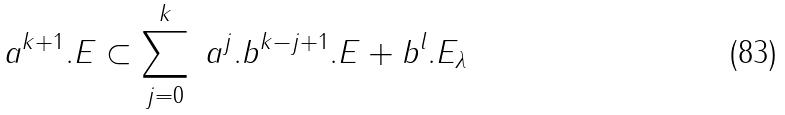Convert formula to latex. <formula><loc_0><loc_0><loc_500><loc_500>a ^ { k + 1 } . E \subset \sum _ { j = 0 } ^ { k } \ a ^ { j } . b ^ { k - j + 1 } . E + b ^ { l } . E _ { \lambda }</formula> 